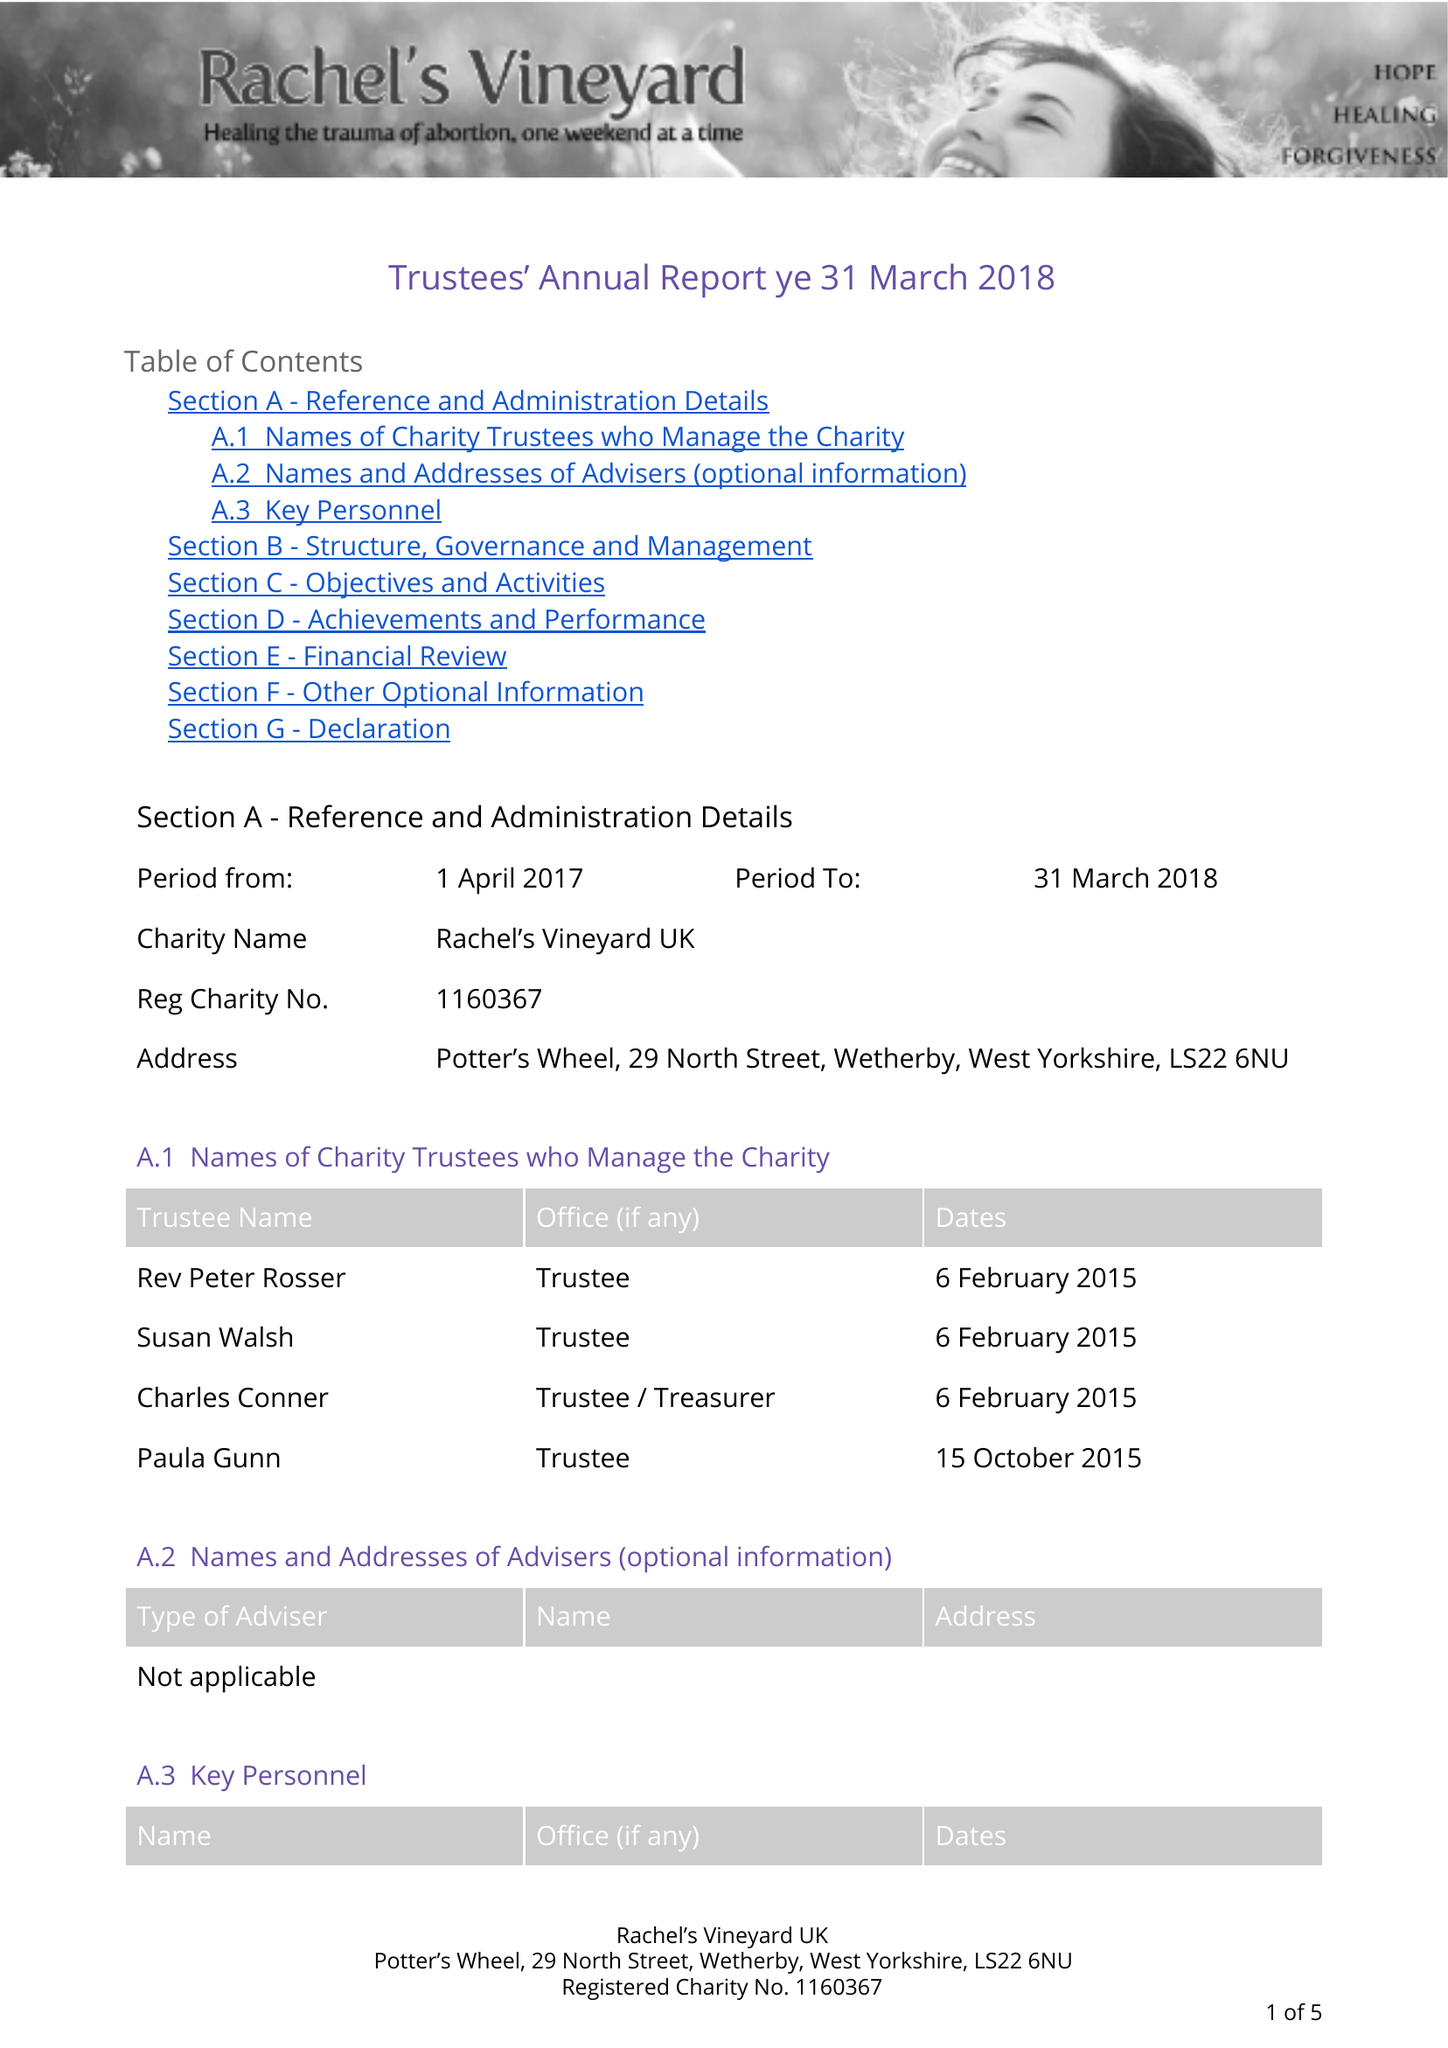What is the value for the charity_number?
Answer the question using a single word or phrase. 1160367 